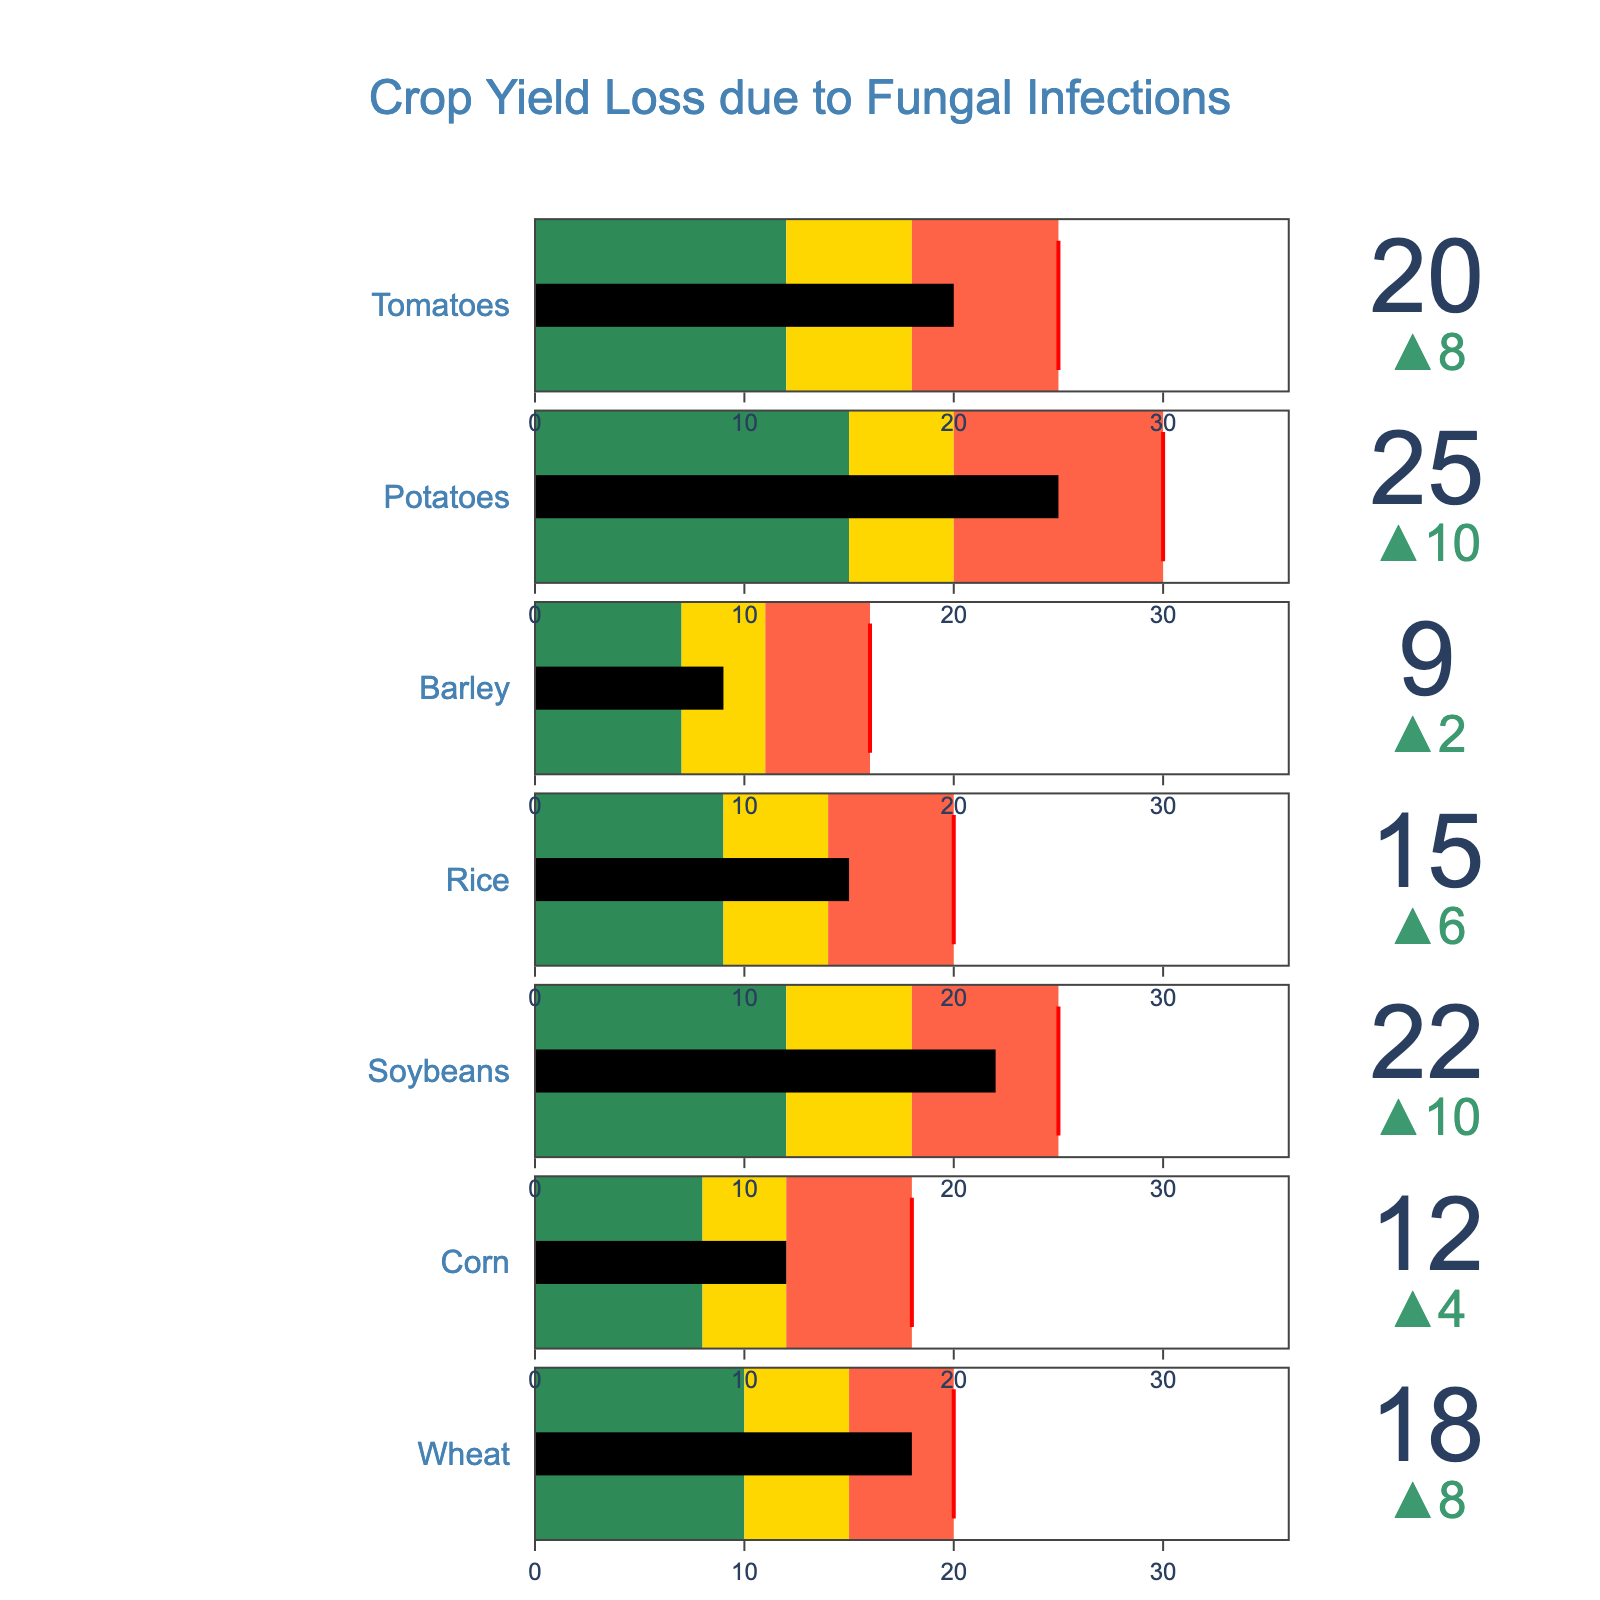what is the actual yield loss for wheat? The figure will show the actual yield loss for each crop, identified by their respective names. For wheat, locate its corresponding bar and read the actual yield loss value.
Answer: 18% what is the color of the bar when the actual yield loss is below the target threshold? The color scheme is described, and for values below the target threshold, the color is specifically assigned. The color palette indicates that the color for values below the target threshold is green.
Answer: Green which crop has the highest actual yield loss? By comparing the values displayed for each crop's actual yield loss, identify the crop with the highest value. According to the figure, the highest actual yield loss is 25%, which corresponds to potatoes.
Answer: Potatoes is the actual yield loss for rice above the warning threshold? Identify the actual yield loss for rice and compare it to its warning threshold. The actual yield loss for rice is 15%, and its warning threshold is 14%. Since 15% is above 14%, the actual yield loss is indeed above the warning threshold.
Answer: Yes what is the difference between the actual yield loss and the critical threshold for tomatoes? Subtract the actual yield loss value for tomatoes from its critical threshold value. The actual yield loss for tomatoes is 20%, and its critical threshold is 25%. The difference is 25% - 20% = 5%.
Answer: 5% how many crops have an actual yield loss below their target threshold? Check each crop's actual yield loss and compare it to their respective target thresholds. Count the number of crops where the actual yield loss is below the target threshold. Only barley with 9% actual yield loss is below its target threshold of 11%.
Answer: 1 do any crops have an actual yield loss that meets or exceeds their critical threshold? Compare the actual yield loss values to their respective critical thresholds to see if any crop's actual yield loss is equal to or higher than the critical threshold. No crop's actual yield loss meets or exceeds its critical threshold (e.g., wheat's actual yield loss of 18% is below a critical threshold of 20%).
Answer: No which crop has the smallest margin between actual yield loss and the target threshold? Calculate the margin for each crop by subtracting the actual yield loss from the target threshold, and identify the smallest one. For barley, the actual yield loss is 9% and the target threshold is 7%, resulting in a margin of -2%.
Answer: Barley if the target threshold for corn were to increase by 2 percentage points, what would the new target threshold be? Add 2 percentage points to the current target threshold for corn, which is 8%. The new target threshold would thus be 10% (8% + 2%).
Answer: 10% how many crops have an actual yield loss between the warning and critical thresholds? Check each crop's actual yield loss to see if it falls within their respective warning and critical threshold ranges. Count the number of crops meeting this criteria.
Answer: 4 